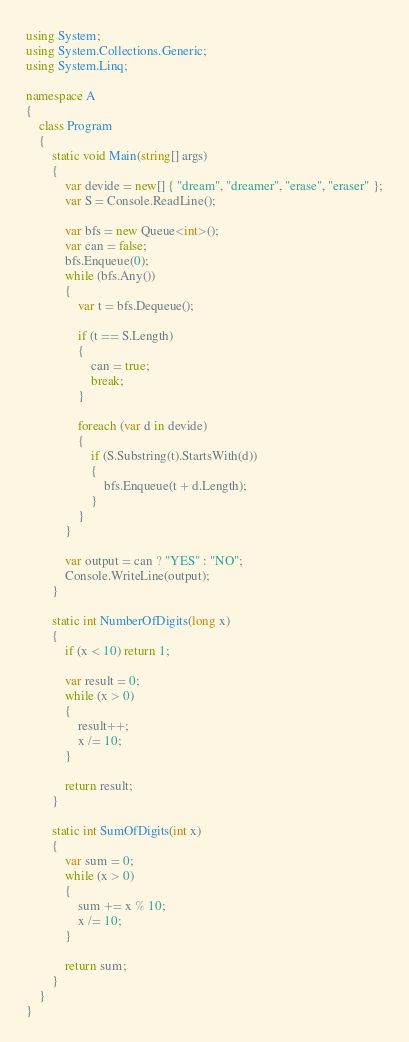<code> <loc_0><loc_0><loc_500><loc_500><_C#_>using System;
using System.Collections.Generic;
using System.Linq;

namespace A
{
    class Program
    {
        static void Main(string[] args)
        {
            var devide = new[] { "dream", "dreamer", "erase", "eraser" };
            var S = Console.ReadLine();

            var bfs = new Queue<int>();
            var can = false;
            bfs.Enqueue(0);
            while (bfs.Any())
            {
                var t = bfs.Dequeue();

                if (t == S.Length)
                {
                    can = true;
                    break;
                }

                foreach (var d in devide)
                {
                    if (S.Substring(t).StartsWith(d))
                    {
                        bfs.Enqueue(t + d.Length);
                    }
                }
            }

            var output = can ? "YES" : "NO";
            Console.WriteLine(output);
        }

        static int NumberOfDigits(long x)
        {
            if (x < 10) return 1;

            var result = 0;
            while (x > 0)
            {
                result++;
                x /= 10;
            }

            return result;
        }

        static int SumOfDigits(int x)
        {
            var sum = 0;
            while (x > 0)
            {
                sum += x % 10;
                x /= 10;
            }

            return sum;
        }
    }
}
</code> 